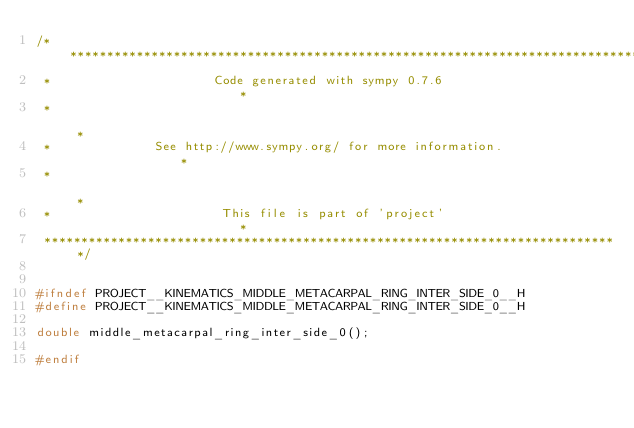<code> <loc_0><loc_0><loc_500><loc_500><_C_>/******************************************************************************
 *                      Code generated with sympy 0.7.6                       *
 *                                                                            *
 *              See http://www.sympy.org/ for more information.               *
 *                                                                            *
 *                       This file is part of 'project'                       *
 ******************************************************************************/


#ifndef PROJECT__KINEMATICS_MIDDLE_METACARPAL_RING_INTER_SIDE_0__H
#define PROJECT__KINEMATICS_MIDDLE_METACARPAL_RING_INTER_SIDE_0__H

double middle_metacarpal_ring_inter_side_0();

#endif

</code> 